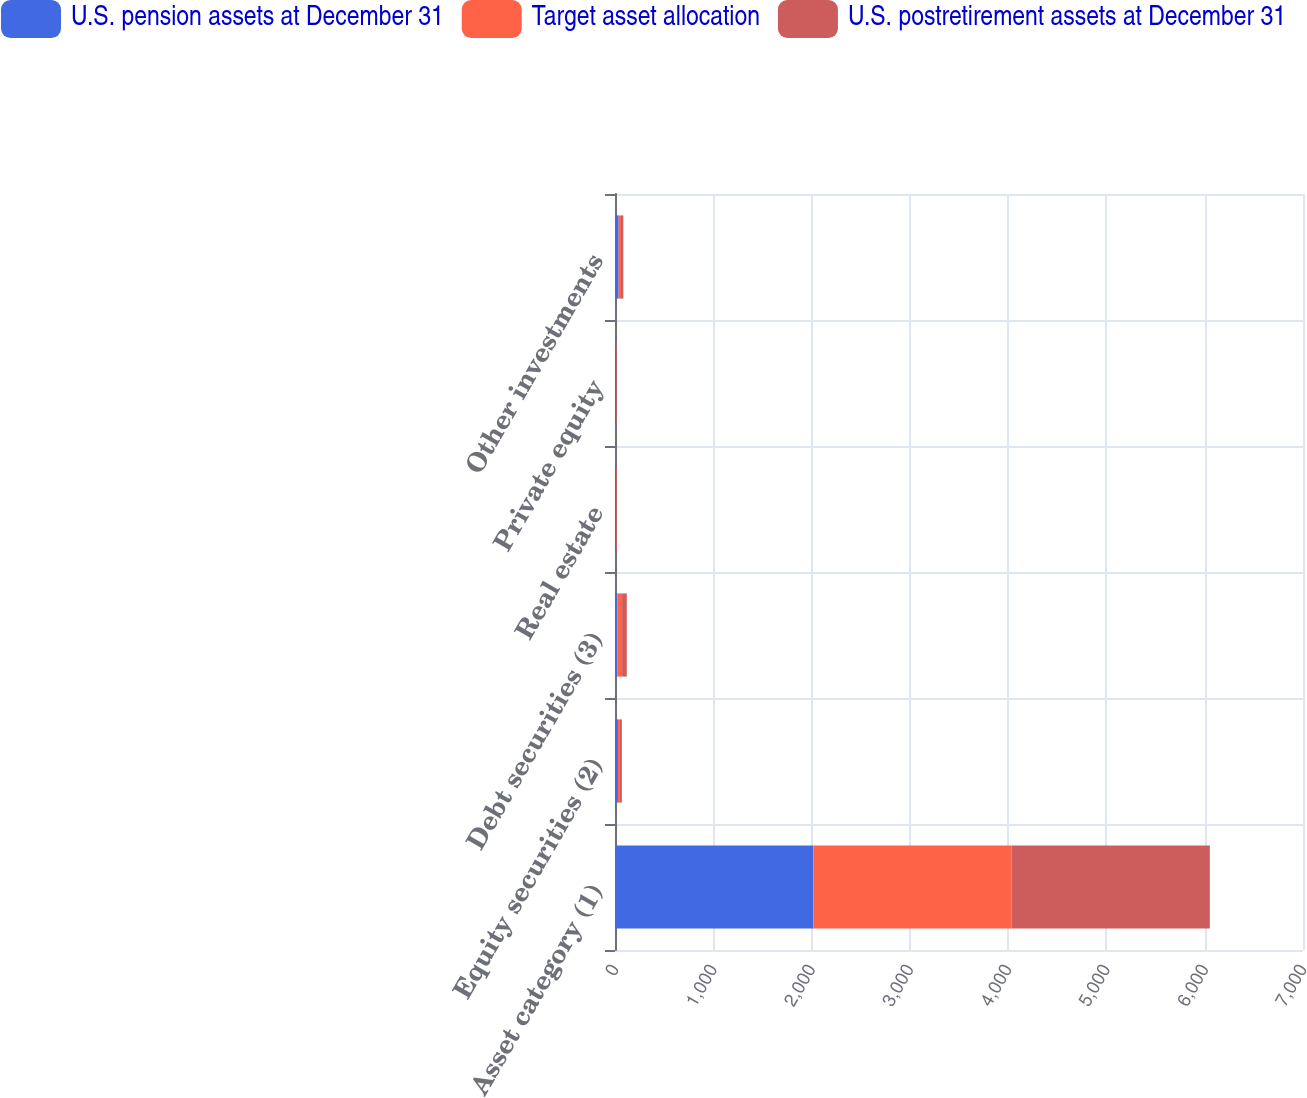Convert chart. <chart><loc_0><loc_0><loc_500><loc_500><stacked_bar_chart><ecel><fcel>Asset category (1)<fcel>Equity securities (2)<fcel>Debt securities (3)<fcel>Real estate<fcel>Private equity<fcel>Other investments<nl><fcel>U.S. pension assets at December 31<fcel>2018<fcel>30<fcel>24<fcel>10<fcel>12<fcel>37<nl><fcel>Target asset allocation<fcel>2017<fcel>20<fcel>48<fcel>5<fcel>3<fcel>24<nl><fcel>U.S. postretirement assets at December 31<fcel>2017<fcel>20<fcel>48<fcel>5<fcel>3<fcel>24<nl></chart> 